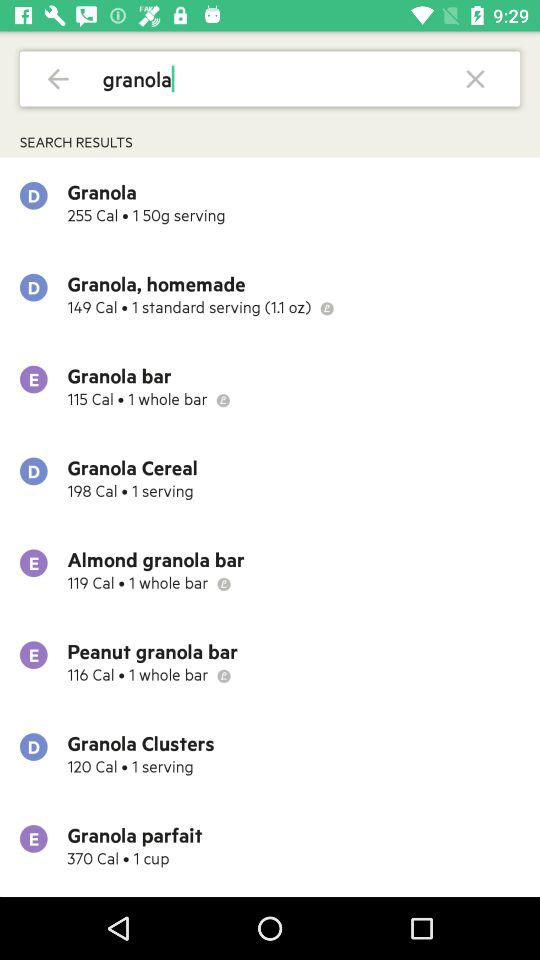What is the number of calories in the "Granola Cereal"? The number of calories in the "Granola Cereal" is 198. 